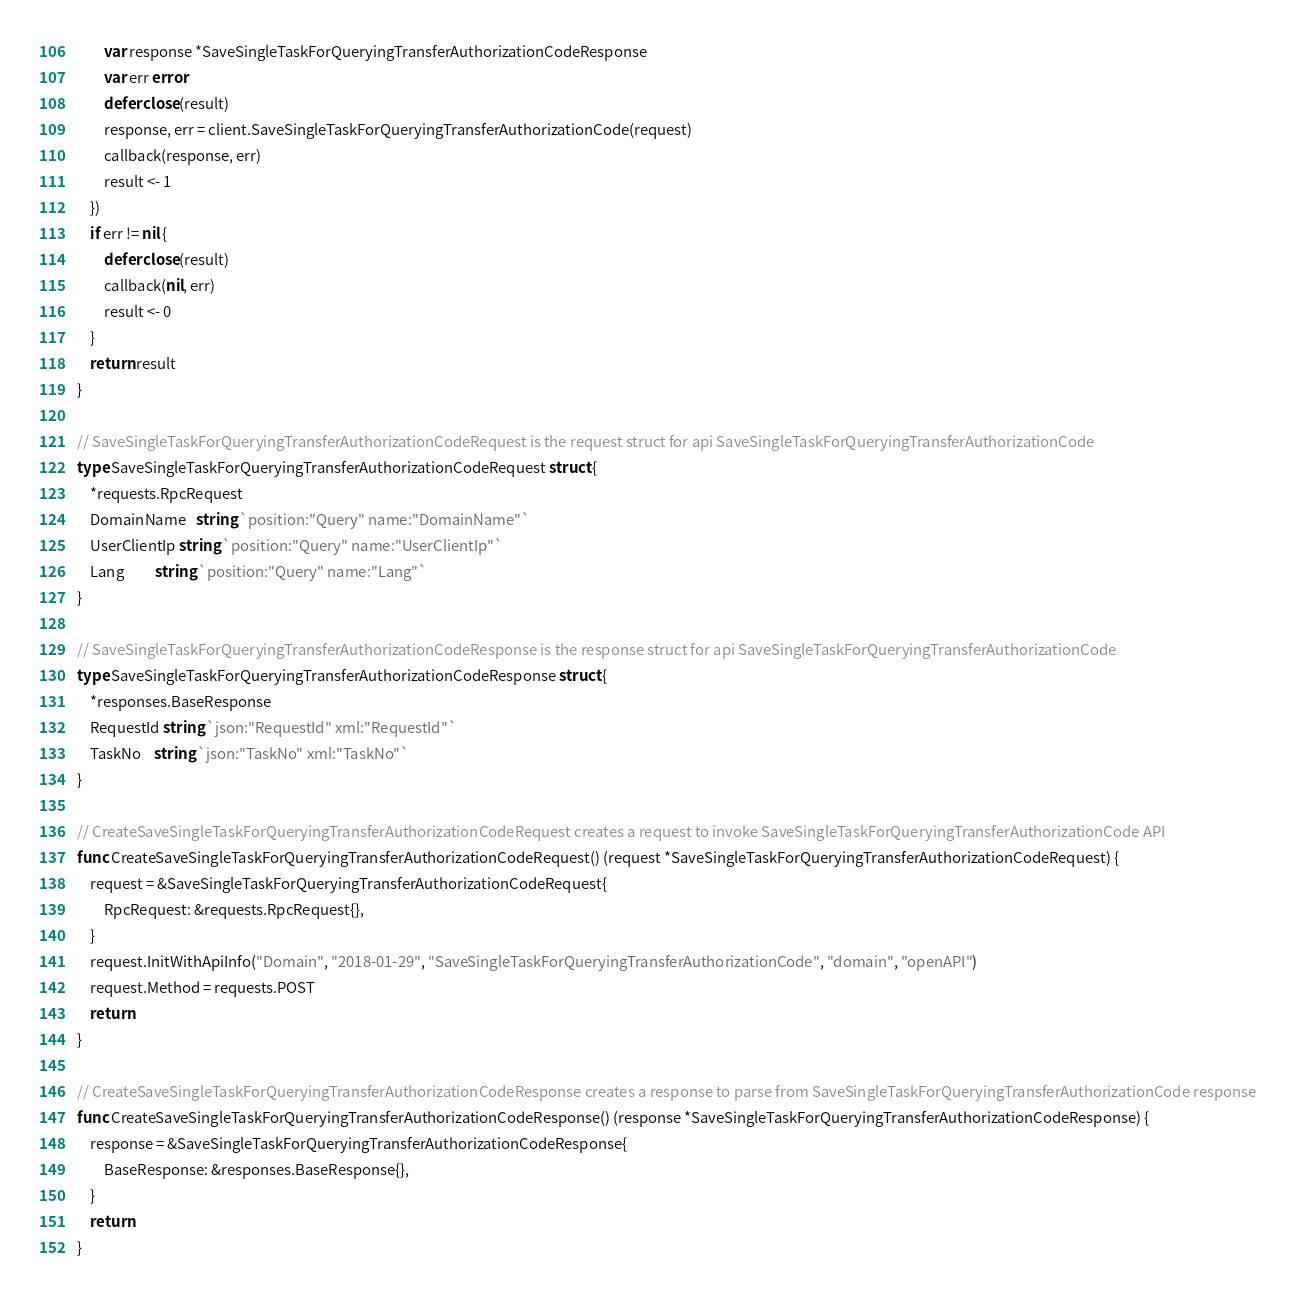<code> <loc_0><loc_0><loc_500><loc_500><_Go_>		var response *SaveSingleTaskForQueryingTransferAuthorizationCodeResponse
		var err error
		defer close(result)
		response, err = client.SaveSingleTaskForQueryingTransferAuthorizationCode(request)
		callback(response, err)
		result <- 1
	})
	if err != nil {
		defer close(result)
		callback(nil, err)
		result <- 0
	}
	return result
}

// SaveSingleTaskForQueryingTransferAuthorizationCodeRequest is the request struct for api SaveSingleTaskForQueryingTransferAuthorizationCode
type SaveSingleTaskForQueryingTransferAuthorizationCodeRequest struct {
	*requests.RpcRequest
	DomainName   string `position:"Query" name:"DomainName"`
	UserClientIp string `position:"Query" name:"UserClientIp"`
	Lang         string `position:"Query" name:"Lang"`
}

// SaveSingleTaskForQueryingTransferAuthorizationCodeResponse is the response struct for api SaveSingleTaskForQueryingTransferAuthorizationCode
type SaveSingleTaskForQueryingTransferAuthorizationCodeResponse struct {
	*responses.BaseResponse
	RequestId string `json:"RequestId" xml:"RequestId"`
	TaskNo    string `json:"TaskNo" xml:"TaskNo"`
}

// CreateSaveSingleTaskForQueryingTransferAuthorizationCodeRequest creates a request to invoke SaveSingleTaskForQueryingTransferAuthorizationCode API
func CreateSaveSingleTaskForQueryingTransferAuthorizationCodeRequest() (request *SaveSingleTaskForQueryingTransferAuthorizationCodeRequest) {
	request = &SaveSingleTaskForQueryingTransferAuthorizationCodeRequest{
		RpcRequest: &requests.RpcRequest{},
	}
	request.InitWithApiInfo("Domain", "2018-01-29", "SaveSingleTaskForQueryingTransferAuthorizationCode", "domain", "openAPI")
	request.Method = requests.POST
	return
}

// CreateSaveSingleTaskForQueryingTransferAuthorizationCodeResponse creates a response to parse from SaveSingleTaskForQueryingTransferAuthorizationCode response
func CreateSaveSingleTaskForQueryingTransferAuthorizationCodeResponse() (response *SaveSingleTaskForQueryingTransferAuthorizationCodeResponse) {
	response = &SaveSingleTaskForQueryingTransferAuthorizationCodeResponse{
		BaseResponse: &responses.BaseResponse{},
	}
	return
}
</code> 